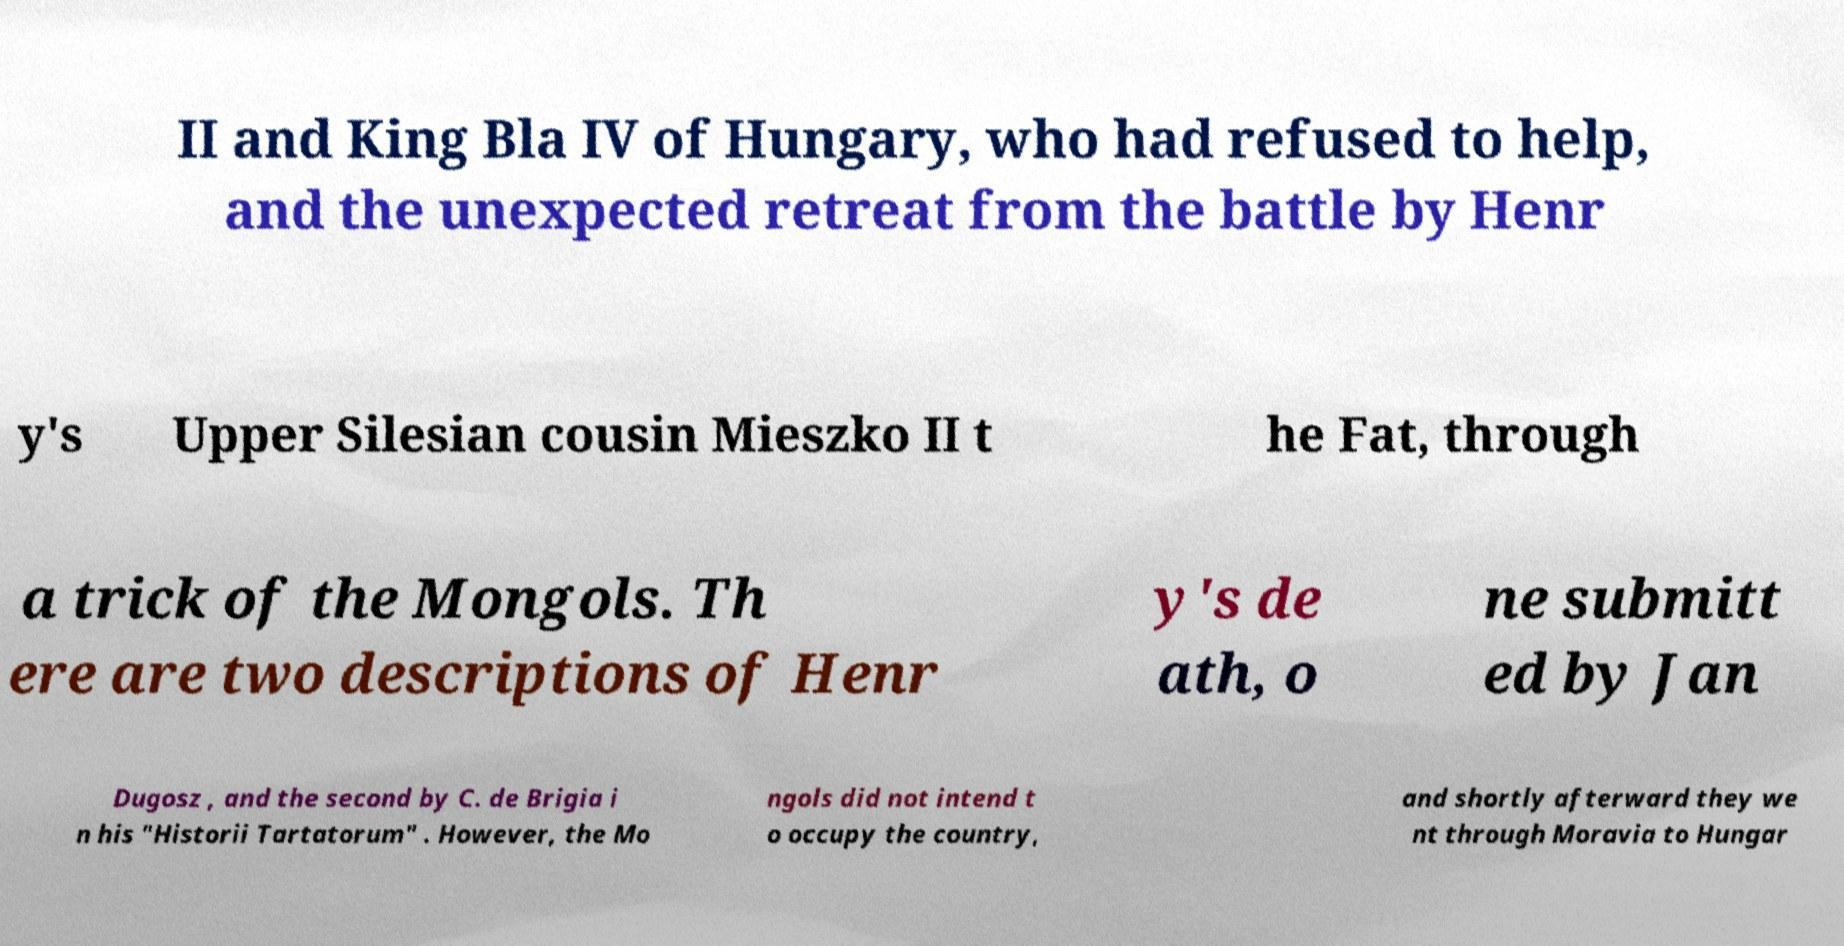I need the written content from this picture converted into text. Can you do that? II and King Bla IV of Hungary, who had refused to help, and the unexpected retreat from the battle by Henr y's Upper Silesian cousin Mieszko II t he Fat, through a trick of the Mongols. Th ere are two descriptions of Henr y's de ath, o ne submitt ed by Jan Dugosz , and the second by C. de Brigia i n his "Historii Tartatorum" . However, the Mo ngols did not intend t o occupy the country, and shortly afterward they we nt through Moravia to Hungar 